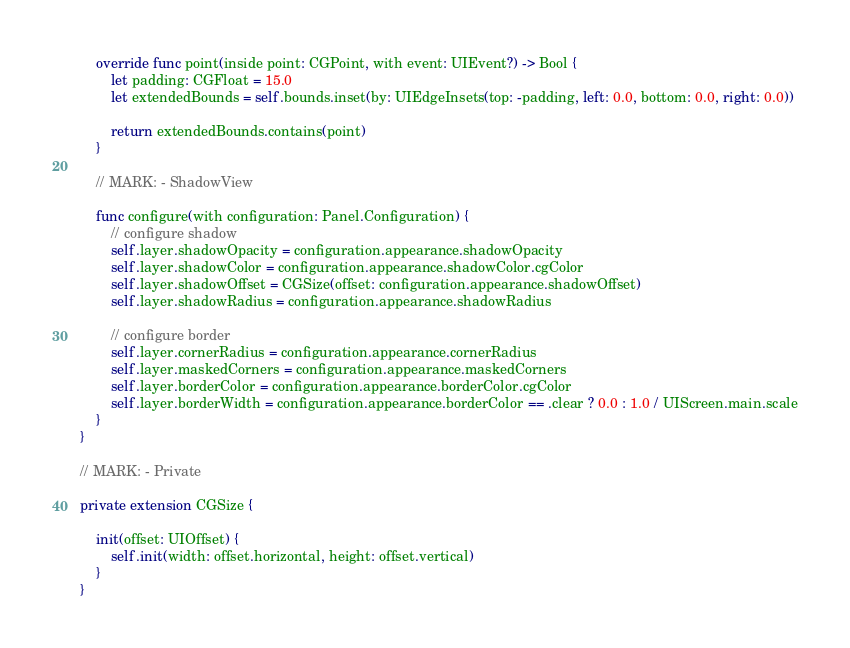Convert code to text. <code><loc_0><loc_0><loc_500><loc_500><_Swift_>
    override func point(inside point: CGPoint, with event: UIEvent?) -> Bool {
        let padding: CGFloat = 15.0
        let extendedBounds = self.bounds.inset(by: UIEdgeInsets(top: -padding, left: 0.0, bottom: 0.0, right: 0.0))

        return extendedBounds.contains(point)
    }

    // MARK: - ShadowView

    func configure(with configuration: Panel.Configuration) {
        // configure shadow
        self.layer.shadowOpacity = configuration.appearance.shadowOpacity
        self.layer.shadowColor = configuration.appearance.shadowColor.cgColor
        self.layer.shadowOffset = CGSize(offset: configuration.appearance.shadowOffset)
        self.layer.shadowRadius = configuration.appearance.shadowRadius

        // configure border
        self.layer.cornerRadius = configuration.appearance.cornerRadius
        self.layer.maskedCorners = configuration.appearance.maskedCorners
        self.layer.borderColor = configuration.appearance.borderColor.cgColor
        self.layer.borderWidth = configuration.appearance.borderColor == .clear ? 0.0 : 1.0 / UIScreen.main.scale
    }
}

// MARK: - Private

private extension CGSize {

    init(offset: UIOffset) {
        self.init(width: offset.horizontal, height: offset.vertical)
    }
}
</code> 